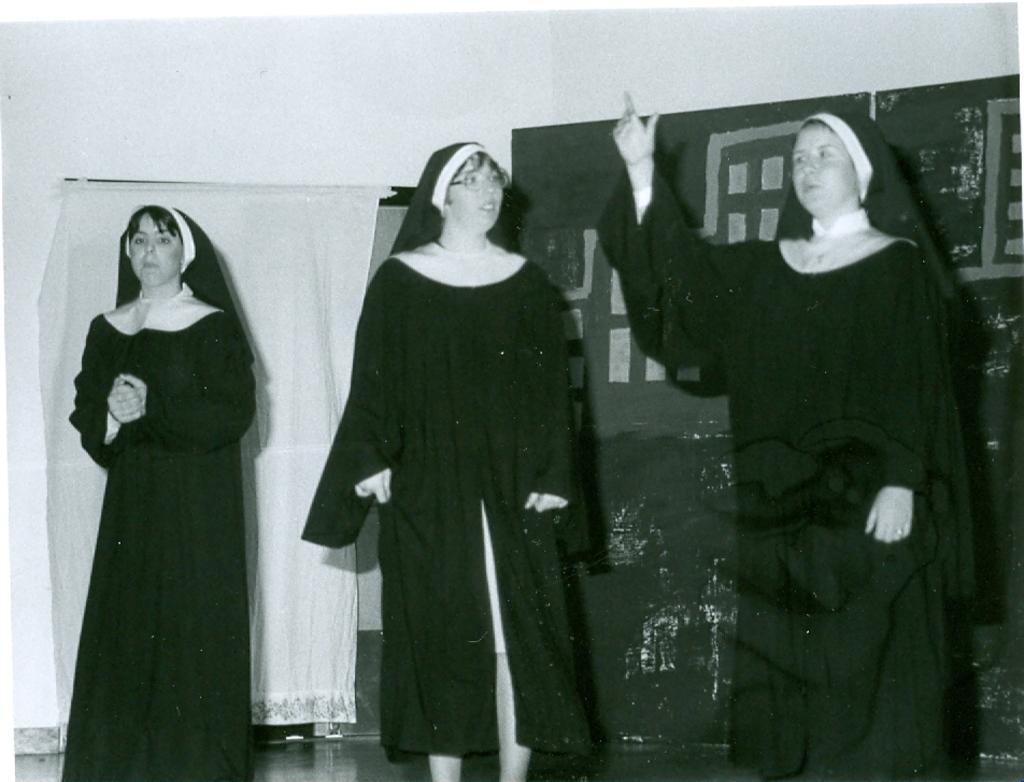Please provide a concise description of this image. This is a black and white picture. Here we can see three persons are standing on the floor. In the background we can see a curtain, wall, and an object. 